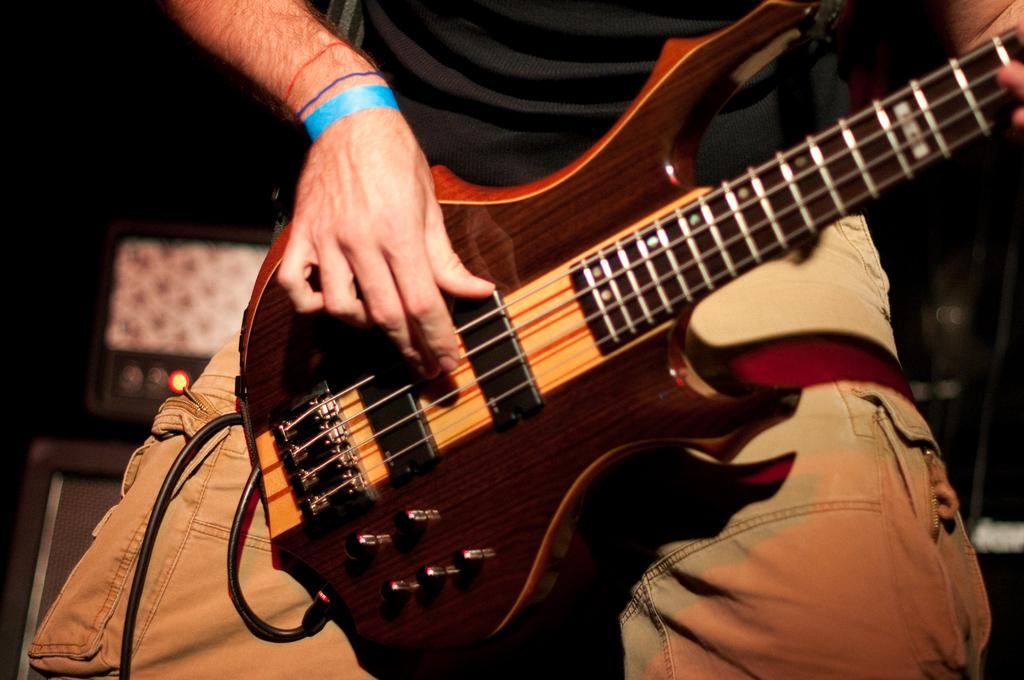What is the main subject of the image? The main subject of the image is a man. What is the man holding in the image? The man is holding a guitar. What type of spring can be seen in the image? There is no spring present in the image; it features a man holding a guitar. How old is the man's son in the image? There is no son present in the image, only the man holding a guitar. 